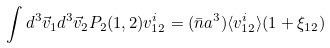Convert formula to latex. <formula><loc_0><loc_0><loc_500><loc_500>\int d ^ { 3 } \vec { v } _ { 1 } d ^ { 3 } \vec { v } _ { 2 } P _ { 2 } ( 1 , 2 ) v _ { 1 2 } ^ { i } = ( \bar { n } a ^ { 3 } ) \langle v _ { 1 2 } ^ { i } \rangle ( 1 + \xi _ { 1 2 } )</formula> 